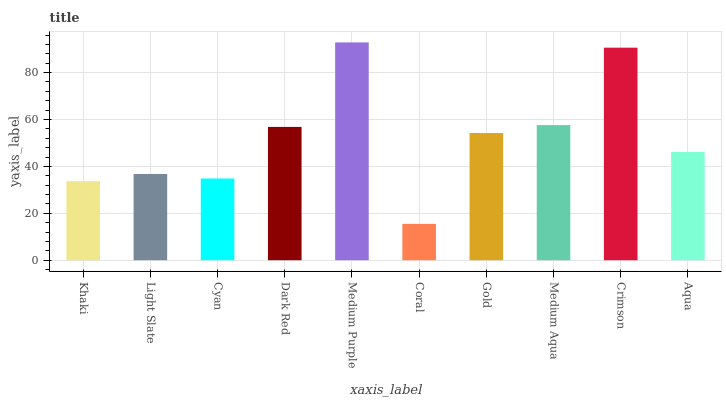Is Coral the minimum?
Answer yes or no. Yes. Is Medium Purple the maximum?
Answer yes or no. Yes. Is Light Slate the minimum?
Answer yes or no. No. Is Light Slate the maximum?
Answer yes or no. No. Is Light Slate greater than Khaki?
Answer yes or no. Yes. Is Khaki less than Light Slate?
Answer yes or no. Yes. Is Khaki greater than Light Slate?
Answer yes or no. No. Is Light Slate less than Khaki?
Answer yes or no. No. Is Gold the high median?
Answer yes or no. Yes. Is Aqua the low median?
Answer yes or no. Yes. Is Cyan the high median?
Answer yes or no. No. Is Gold the low median?
Answer yes or no. No. 